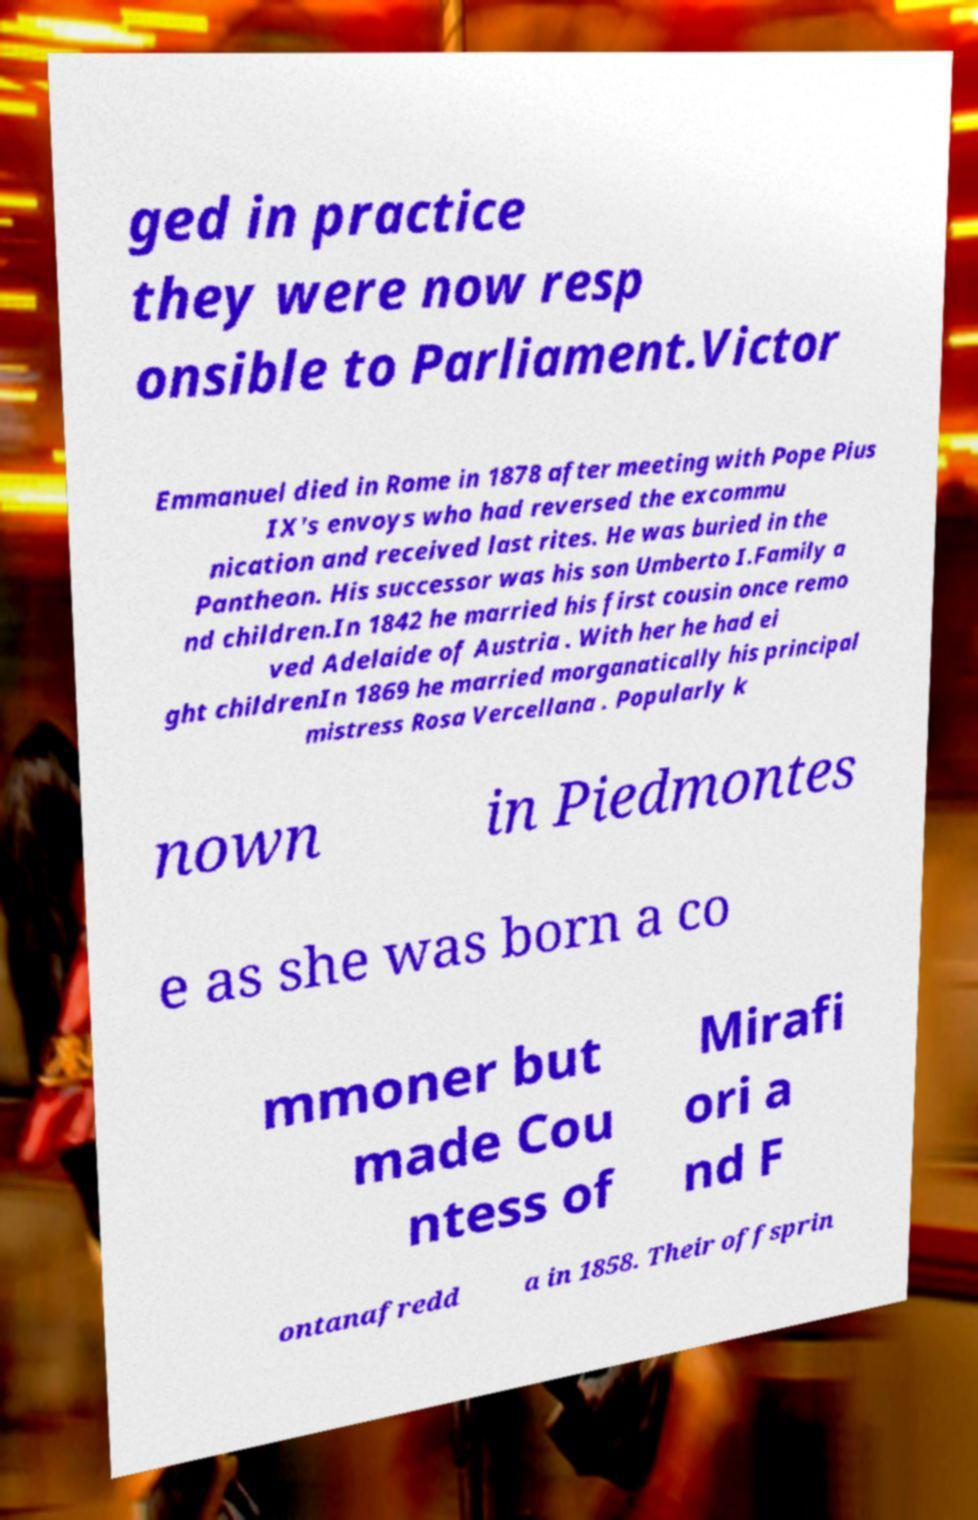Could you extract and type out the text from this image? ged in practice they were now resp onsible to Parliament.Victor Emmanuel died in Rome in 1878 after meeting with Pope Pius IX's envoys who had reversed the excommu nication and received last rites. He was buried in the Pantheon. His successor was his son Umberto I.Family a nd children.In 1842 he married his first cousin once remo ved Adelaide of Austria . With her he had ei ght childrenIn 1869 he married morganatically his principal mistress Rosa Vercellana . Popularly k nown in Piedmontes e as she was born a co mmoner but made Cou ntess of Mirafi ori a nd F ontanafredd a in 1858. Their offsprin 